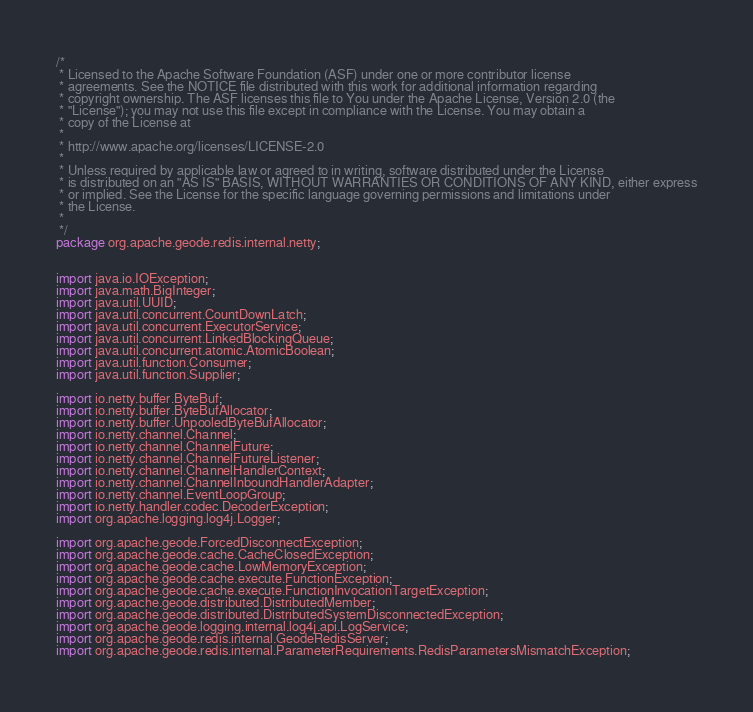Convert code to text. <code><loc_0><loc_0><loc_500><loc_500><_Java_>/*
 * Licensed to the Apache Software Foundation (ASF) under one or more contributor license
 * agreements. See the NOTICE file distributed with this work for additional information regarding
 * copyright ownership. The ASF licenses this file to You under the Apache License, Version 2.0 (the
 * "License"); you may not use this file except in compliance with the License. You may obtain a
 * copy of the License at
 *
 * http://www.apache.org/licenses/LICENSE-2.0
 *
 * Unless required by applicable law or agreed to in writing, software distributed under the License
 * is distributed on an "AS IS" BASIS, WITHOUT WARRANTIES OR CONDITIONS OF ANY KIND, either express
 * or implied. See the License for the specific language governing permissions and limitations under
 * the License.
 *
 */
package org.apache.geode.redis.internal.netty;


import java.io.IOException;
import java.math.BigInteger;
import java.util.UUID;
import java.util.concurrent.CountDownLatch;
import java.util.concurrent.ExecutorService;
import java.util.concurrent.LinkedBlockingQueue;
import java.util.concurrent.atomic.AtomicBoolean;
import java.util.function.Consumer;
import java.util.function.Supplier;

import io.netty.buffer.ByteBuf;
import io.netty.buffer.ByteBufAllocator;
import io.netty.buffer.UnpooledByteBufAllocator;
import io.netty.channel.Channel;
import io.netty.channel.ChannelFuture;
import io.netty.channel.ChannelFutureListener;
import io.netty.channel.ChannelHandlerContext;
import io.netty.channel.ChannelInboundHandlerAdapter;
import io.netty.channel.EventLoopGroup;
import io.netty.handler.codec.DecoderException;
import org.apache.logging.log4j.Logger;

import org.apache.geode.ForcedDisconnectException;
import org.apache.geode.cache.CacheClosedException;
import org.apache.geode.cache.LowMemoryException;
import org.apache.geode.cache.execute.FunctionException;
import org.apache.geode.cache.execute.FunctionInvocationTargetException;
import org.apache.geode.distributed.DistributedMember;
import org.apache.geode.distributed.DistributedSystemDisconnectedException;
import org.apache.geode.logging.internal.log4j.api.LogService;
import org.apache.geode.redis.internal.GeodeRedisServer;
import org.apache.geode.redis.internal.ParameterRequirements.RedisParametersMismatchException;</code> 